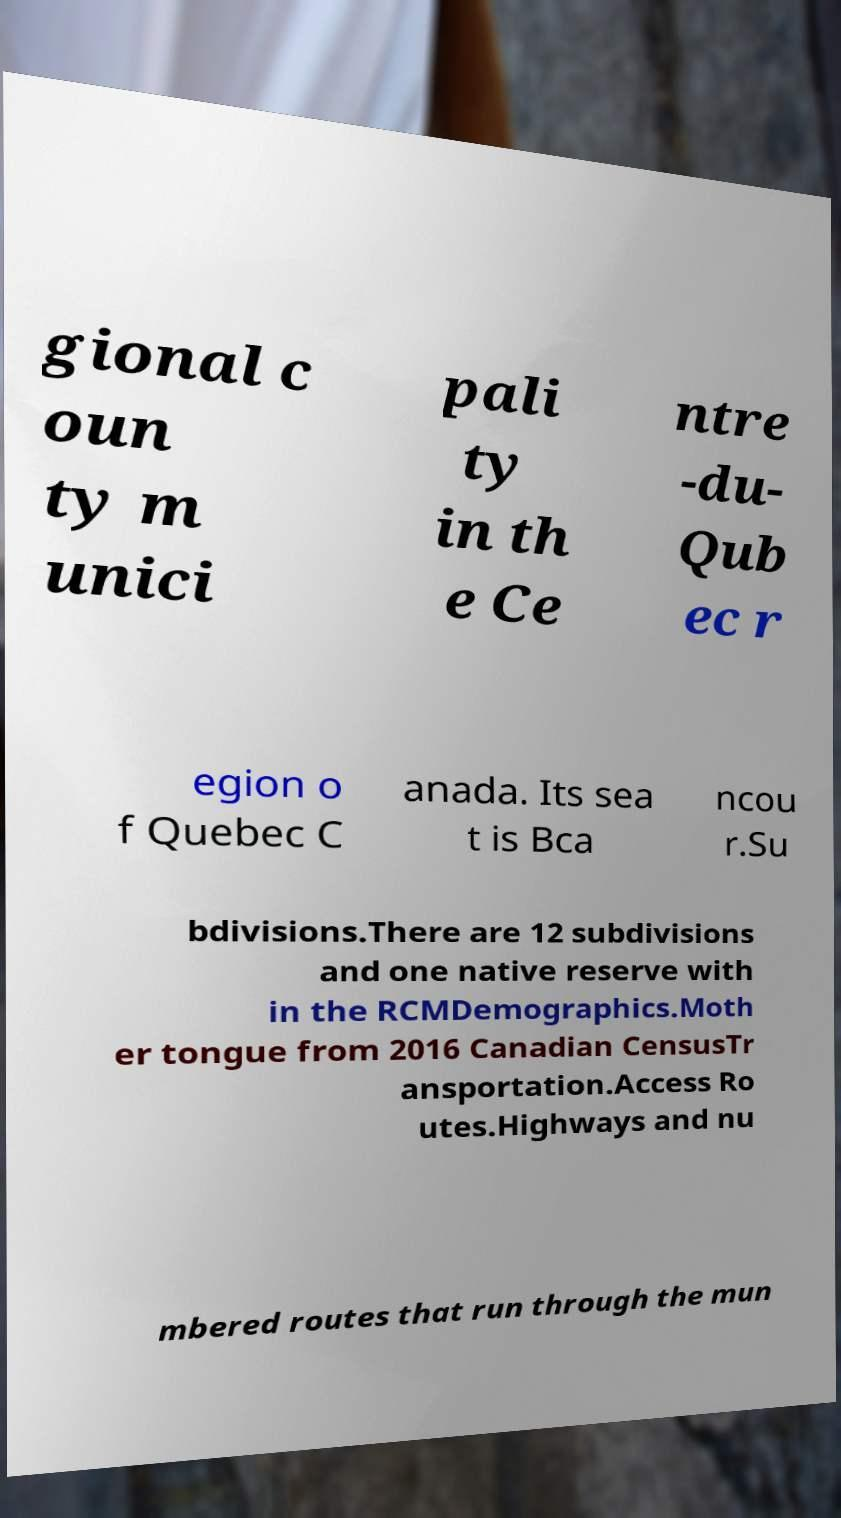For documentation purposes, I need the text within this image transcribed. Could you provide that? gional c oun ty m unici pali ty in th e Ce ntre -du- Qub ec r egion o f Quebec C anada. Its sea t is Bca ncou r.Su bdivisions.There are 12 subdivisions and one native reserve with in the RCMDemographics.Moth er tongue from 2016 Canadian CensusTr ansportation.Access Ro utes.Highways and nu mbered routes that run through the mun 